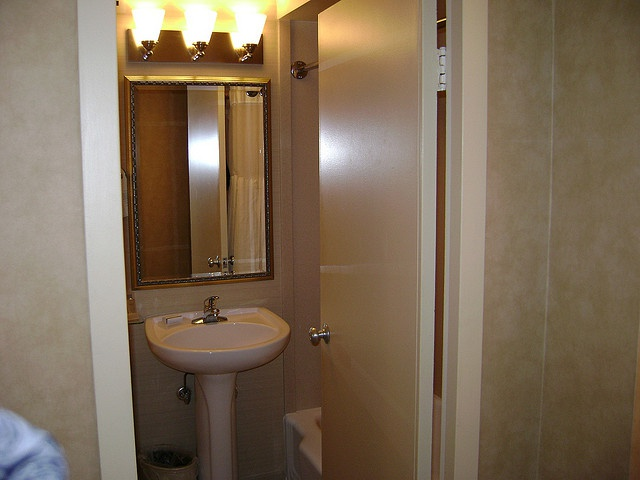Describe the objects in this image and their specific colors. I can see a sink in gray, maroon, and olive tones in this image. 